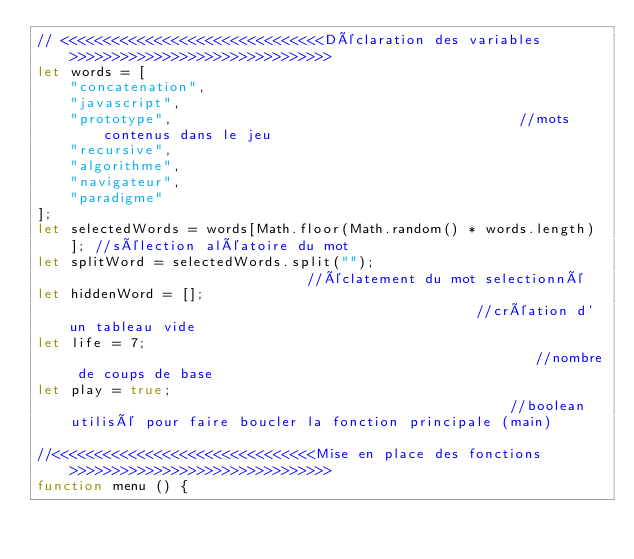Convert code to text. <code><loc_0><loc_0><loc_500><loc_500><_JavaScript_>// <<<<<<<<<<<<<<<<<<<<<<<<<<<<<<<Déclaration des variables>>>>>>>>>>>>>>>>>>>>>>>>>>>>>>>
let words = [                              
    "concatenation",
    "javascript",           
    "prototype",                                         //mots contenus dans le jeu
    "recursive",
    "algorithme",
    "navigateur",
    "paradigme"
];
let selectedWords = words[Math.floor(Math.random() * words.length)]; //sélection aléatoire du mot
let splitWord = selectedWords.split("");                             //éclatement du mot selectionné 
let hiddenWord = [];                                                 //création d'un tableau vide
let life = 7;                                                        //nombre de coups de base
let play = true;                                                     //boolean utilisé pour faire boucler la fonction principale (main)

//<<<<<<<<<<<<<<<<<<<<<<<<<<<<<<<Mise en place des fonctions>>>>>>>>>>>>>>>>>>>>>>>>>>>>>>>
function menu () {</code> 